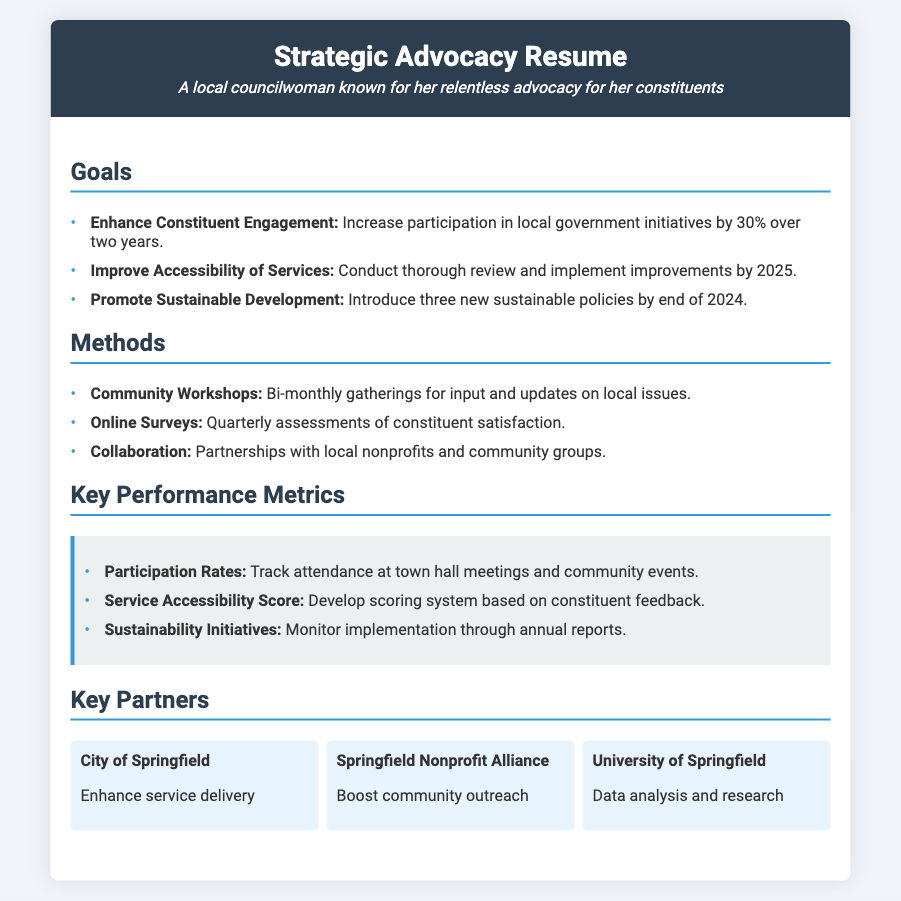what is the goal for enhancing constituent engagement? The goal is to increase participation in local government initiatives by 30% over two years.
Answer: 30% by what year does the councilwoman plan to improve accessibility of services? The councilwoman aims to implement improvements by 2025.
Answer: 2025 how often are community workshops held? Community workshops are held bi-monthly for input and updates.
Answer: bi-monthly how many new sustainable policies does the councilwoman plan to introduce by the end of 2024? The plan is to introduce three new sustainable policies by the end of 2024.
Answer: three what organization partners with the councilwoman to boost community outreach? The Springfield Nonprofit Alliance partners for boosting community outreach.
Answer: Springfield Nonprofit Alliance what key performance metric involves tracking attendance? The key performance metric is Participation Rates which involves tracking attendance at town hall meetings.
Answer: Participation Rates 